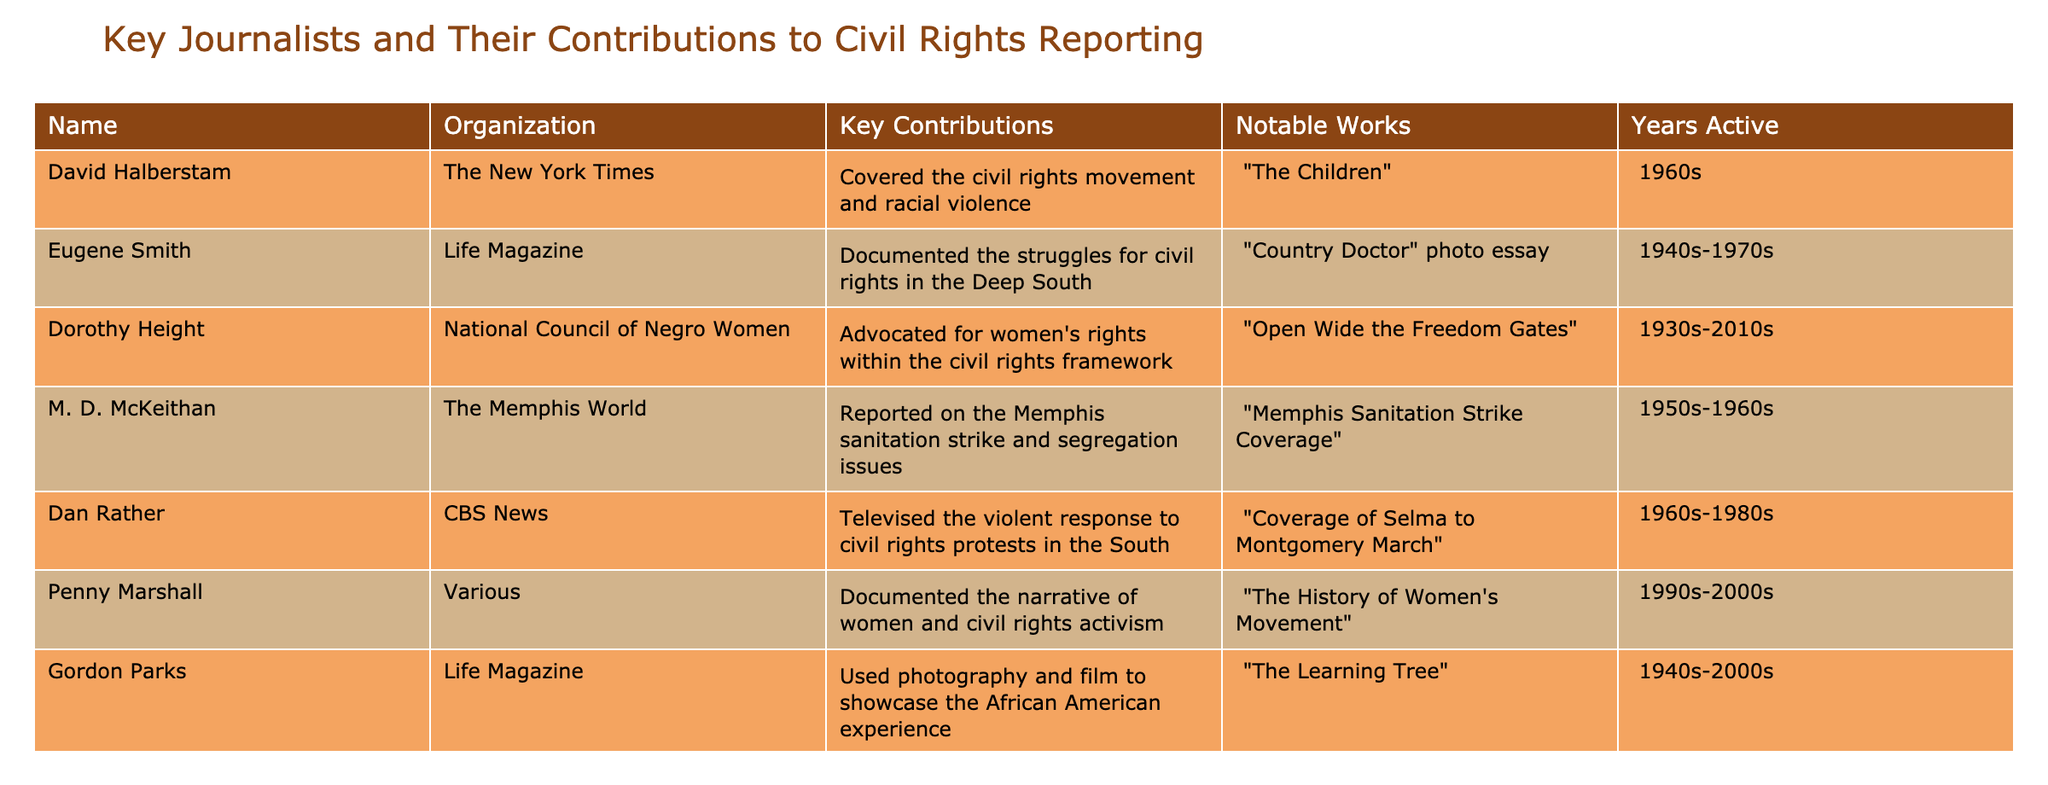What organization was Dorothy Height associated with? The table clearly lists the organization associated with each journalist. For Dorothy Height, the entry states "National Council of Negro Women."
Answer: National Council of Negro Women Who documented the struggles for civil rights in the Deep South? According to the table, Eugene Smith is noted for documenting civil rights struggles specifically in the Deep South.
Answer: Eugene Smith How many years was Dan Rather active in civil rights reporting? The table indicates that Dan Rather was active from the 1960s to the 1980s, which spans 20 years in total.
Answer: 20 years Did Gordon Parks contribute to civil rights reporting? Looking at the table, Gordon Parks is noted for using photography and film to showcase the African American experience, indicating his contribution to civil rights reporting. Thus, the answer is yes.
Answer: Yes Identify the notable work by M. D. McKeithan. The table lists "Memphis Sanitation Strike Coverage" as the notable work by M. D. McKeithan, which can be directly retrieved from the specified row.
Answer: Memphis Sanitation Strike Coverage Which journalist's contributions spanned the longest time? To find the longest span, we check the active years of each journalist. Dorothy Height was active from the 1930s to the 2010s, which gives her an active span of approximately 80 years, the longest reported in the table.
Answer: 80 years How many journalists reported on issues related to women’s rights? In reviewing the table, both Dorothy Height and Penny Marshall are recognized for their contributions to civil rights with a focus on women’s rights, indicating there are two such journalists.
Answer: 2 journalists What notable work did John Howard Griffin publish? The table identifies "Black Like Me" as the notable work published by John Howard Griffin, which can be easily found in the relevant column.
Answer: Black Like Me Did any of the journalists document the Selma to Montgomery march? The table indicates that Dan Rather covered the Selma to Montgomery march, confirming that indeed one journalist reported this significant historical event.
Answer: Yes What was the main contribution of David Halberstam in civil rights reporting? David Halberstam's main contribution, as noted in the table, was covering the civil rights movement and racial violence, which can be directly identified in his entry.
Answer: Covered civil rights movement and racial violence 